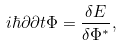Convert formula to latex. <formula><loc_0><loc_0><loc_500><loc_500>i \hbar { } { \partial } { \partial t } \Phi = \frac { \delta E } { \delta \Phi ^ { * } } ,</formula> 